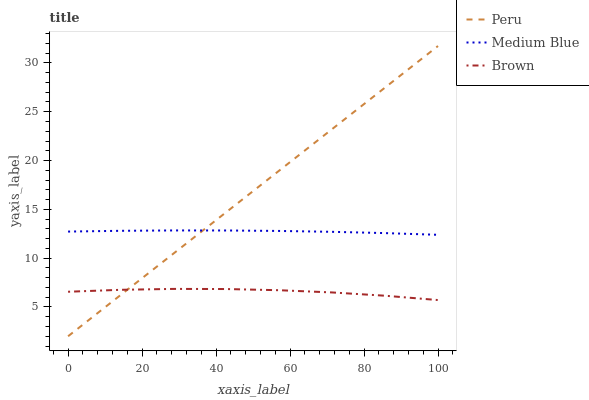Does Brown have the minimum area under the curve?
Answer yes or no. Yes. Does Peru have the maximum area under the curve?
Answer yes or no. Yes. Does Medium Blue have the minimum area under the curve?
Answer yes or no. No. Does Medium Blue have the maximum area under the curve?
Answer yes or no. No. Is Peru the smoothest?
Answer yes or no. Yes. Is Brown the roughest?
Answer yes or no. Yes. Is Medium Blue the smoothest?
Answer yes or no. No. Is Medium Blue the roughest?
Answer yes or no. No. Does Peru have the lowest value?
Answer yes or no. Yes. Does Medium Blue have the lowest value?
Answer yes or no. No. Does Peru have the highest value?
Answer yes or no. Yes. Does Medium Blue have the highest value?
Answer yes or no. No. Is Brown less than Medium Blue?
Answer yes or no. Yes. Is Medium Blue greater than Brown?
Answer yes or no. Yes. Does Peru intersect Medium Blue?
Answer yes or no. Yes. Is Peru less than Medium Blue?
Answer yes or no. No. Is Peru greater than Medium Blue?
Answer yes or no. No. Does Brown intersect Medium Blue?
Answer yes or no. No. 